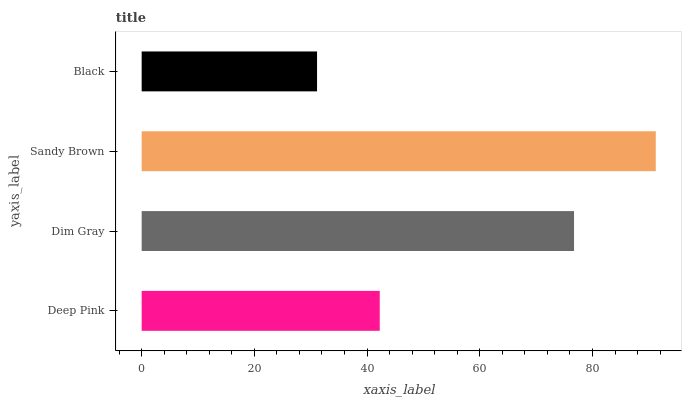Is Black the minimum?
Answer yes or no. Yes. Is Sandy Brown the maximum?
Answer yes or no. Yes. Is Dim Gray the minimum?
Answer yes or no. No. Is Dim Gray the maximum?
Answer yes or no. No. Is Dim Gray greater than Deep Pink?
Answer yes or no. Yes. Is Deep Pink less than Dim Gray?
Answer yes or no. Yes. Is Deep Pink greater than Dim Gray?
Answer yes or no. No. Is Dim Gray less than Deep Pink?
Answer yes or no. No. Is Dim Gray the high median?
Answer yes or no. Yes. Is Deep Pink the low median?
Answer yes or no. Yes. Is Black the high median?
Answer yes or no. No. Is Sandy Brown the low median?
Answer yes or no. No. 